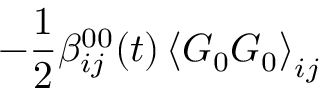<formula> <loc_0><loc_0><loc_500><loc_500>- \frac { 1 } { 2 } \beta _ { i j } ^ { 0 0 } ( t ) \left \langle G _ { 0 } G _ { 0 } \right \rangle _ { i j }</formula> 